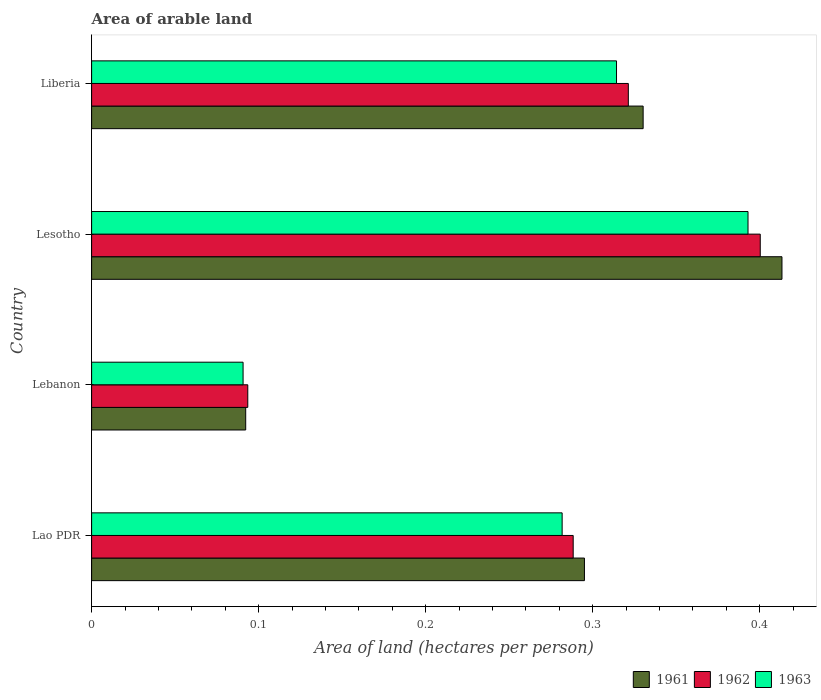How many different coloured bars are there?
Keep it short and to the point. 3. Are the number of bars on each tick of the Y-axis equal?
Offer a very short reply. Yes. How many bars are there on the 4th tick from the top?
Give a very brief answer. 3. How many bars are there on the 2nd tick from the bottom?
Make the answer very short. 3. What is the label of the 3rd group of bars from the top?
Provide a succinct answer. Lebanon. In how many cases, is the number of bars for a given country not equal to the number of legend labels?
Offer a very short reply. 0. What is the total arable land in 1961 in Lesotho?
Keep it short and to the point. 0.41. Across all countries, what is the maximum total arable land in 1963?
Keep it short and to the point. 0.39. Across all countries, what is the minimum total arable land in 1961?
Make the answer very short. 0.09. In which country was the total arable land in 1961 maximum?
Ensure brevity in your answer.  Lesotho. In which country was the total arable land in 1963 minimum?
Your answer should be compact. Lebanon. What is the total total arable land in 1962 in the graph?
Provide a succinct answer. 1.1. What is the difference between the total arable land in 1962 in Lesotho and that in Liberia?
Give a very brief answer. 0.08. What is the difference between the total arable land in 1962 in Lao PDR and the total arable land in 1961 in Liberia?
Keep it short and to the point. -0.04. What is the average total arable land in 1961 per country?
Offer a very short reply. 0.28. What is the difference between the total arable land in 1962 and total arable land in 1961 in Lebanon?
Ensure brevity in your answer.  0. What is the ratio of the total arable land in 1963 in Lesotho to that in Liberia?
Your response must be concise. 1.25. Is the total arable land in 1963 in Lebanon less than that in Lesotho?
Ensure brevity in your answer.  Yes. What is the difference between the highest and the second highest total arable land in 1962?
Your answer should be compact. 0.08. What is the difference between the highest and the lowest total arable land in 1961?
Offer a very short reply. 0.32. In how many countries, is the total arable land in 1963 greater than the average total arable land in 1963 taken over all countries?
Your answer should be very brief. 3. Is the sum of the total arable land in 1961 in Lesotho and Liberia greater than the maximum total arable land in 1963 across all countries?
Give a very brief answer. Yes. What does the 1st bar from the top in Lesotho represents?
Your answer should be compact. 1963. What does the 2nd bar from the bottom in Liberia represents?
Ensure brevity in your answer.  1962. Is it the case that in every country, the sum of the total arable land in 1961 and total arable land in 1963 is greater than the total arable land in 1962?
Provide a short and direct response. Yes. How many countries are there in the graph?
Keep it short and to the point. 4. Are the values on the major ticks of X-axis written in scientific E-notation?
Ensure brevity in your answer.  No. Does the graph contain any zero values?
Ensure brevity in your answer.  No. Does the graph contain grids?
Give a very brief answer. No. How are the legend labels stacked?
Provide a succinct answer. Horizontal. What is the title of the graph?
Ensure brevity in your answer.  Area of arable land. What is the label or title of the X-axis?
Give a very brief answer. Area of land (hectares per person). What is the Area of land (hectares per person) in 1961 in Lao PDR?
Keep it short and to the point. 0.3. What is the Area of land (hectares per person) of 1962 in Lao PDR?
Keep it short and to the point. 0.29. What is the Area of land (hectares per person) of 1963 in Lao PDR?
Give a very brief answer. 0.28. What is the Area of land (hectares per person) in 1961 in Lebanon?
Provide a short and direct response. 0.09. What is the Area of land (hectares per person) in 1962 in Lebanon?
Provide a succinct answer. 0.09. What is the Area of land (hectares per person) of 1963 in Lebanon?
Provide a succinct answer. 0.09. What is the Area of land (hectares per person) in 1961 in Lesotho?
Ensure brevity in your answer.  0.41. What is the Area of land (hectares per person) in 1962 in Lesotho?
Offer a terse response. 0.4. What is the Area of land (hectares per person) of 1963 in Lesotho?
Provide a short and direct response. 0.39. What is the Area of land (hectares per person) of 1961 in Liberia?
Offer a very short reply. 0.33. What is the Area of land (hectares per person) of 1962 in Liberia?
Offer a terse response. 0.32. What is the Area of land (hectares per person) of 1963 in Liberia?
Your answer should be compact. 0.31. Across all countries, what is the maximum Area of land (hectares per person) of 1961?
Your response must be concise. 0.41. Across all countries, what is the maximum Area of land (hectares per person) of 1962?
Your answer should be very brief. 0.4. Across all countries, what is the maximum Area of land (hectares per person) in 1963?
Ensure brevity in your answer.  0.39. Across all countries, what is the minimum Area of land (hectares per person) in 1961?
Give a very brief answer. 0.09. Across all countries, what is the minimum Area of land (hectares per person) of 1962?
Your answer should be compact. 0.09. Across all countries, what is the minimum Area of land (hectares per person) in 1963?
Provide a succinct answer. 0.09. What is the total Area of land (hectares per person) in 1961 in the graph?
Ensure brevity in your answer.  1.13. What is the total Area of land (hectares per person) of 1962 in the graph?
Your response must be concise. 1.1. What is the total Area of land (hectares per person) in 1963 in the graph?
Your answer should be very brief. 1.08. What is the difference between the Area of land (hectares per person) in 1961 in Lao PDR and that in Lebanon?
Your answer should be compact. 0.2. What is the difference between the Area of land (hectares per person) of 1962 in Lao PDR and that in Lebanon?
Keep it short and to the point. 0.19. What is the difference between the Area of land (hectares per person) in 1963 in Lao PDR and that in Lebanon?
Offer a very short reply. 0.19. What is the difference between the Area of land (hectares per person) in 1961 in Lao PDR and that in Lesotho?
Ensure brevity in your answer.  -0.12. What is the difference between the Area of land (hectares per person) of 1962 in Lao PDR and that in Lesotho?
Provide a succinct answer. -0.11. What is the difference between the Area of land (hectares per person) of 1963 in Lao PDR and that in Lesotho?
Keep it short and to the point. -0.11. What is the difference between the Area of land (hectares per person) in 1961 in Lao PDR and that in Liberia?
Your answer should be compact. -0.04. What is the difference between the Area of land (hectares per person) of 1962 in Lao PDR and that in Liberia?
Offer a terse response. -0.03. What is the difference between the Area of land (hectares per person) in 1963 in Lao PDR and that in Liberia?
Your answer should be compact. -0.03. What is the difference between the Area of land (hectares per person) in 1961 in Lebanon and that in Lesotho?
Ensure brevity in your answer.  -0.32. What is the difference between the Area of land (hectares per person) in 1962 in Lebanon and that in Lesotho?
Offer a very short reply. -0.31. What is the difference between the Area of land (hectares per person) of 1963 in Lebanon and that in Lesotho?
Your response must be concise. -0.3. What is the difference between the Area of land (hectares per person) in 1961 in Lebanon and that in Liberia?
Offer a terse response. -0.24. What is the difference between the Area of land (hectares per person) in 1962 in Lebanon and that in Liberia?
Your answer should be compact. -0.23. What is the difference between the Area of land (hectares per person) in 1963 in Lebanon and that in Liberia?
Your answer should be compact. -0.22. What is the difference between the Area of land (hectares per person) in 1961 in Lesotho and that in Liberia?
Your answer should be compact. 0.08. What is the difference between the Area of land (hectares per person) in 1962 in Lesotho and that in Liberia?
Your response must be concise. 0.08. What is the difference between the Area of land (hectares per person) in 1963 in Lesotho and that in Liberia?
Give a very brief answer. 0.08. What is the difference between the Area of land (hectares per person) in 1961 in Lao PDR and the Area of land (hectares per person) in 1962 in Lebanon?
Give a very brief answer. 0.2. What is the difference between the Area of land (hectares per person) of 1961 in Lao PDR and the Area of land (hectares per person) of 1963 in Lebanon?
Provide a short and direct response. 0.2. What is the difference between the Area of land (hectares per person) of 1962 in Lao PDR and the Area of land (hectares per person) of 1963 in Lebanon?
Your response must be concise. 0.2. What is the difference between the Area of land (hectares per person) in 1961 in Lao PDR and the Area of land (hectares per person) in 1962 in Lesotho?
Offer a terse response. -0.11. What is the difference between the Area of land (hectares per person) in 1961 in Lao PDR and the Area of land (hectares per person) in 1963 in Lesotho?
Make the answer very short. -0.1. What is the difference between the Area of land (hectares per person) in 1962 in Lao PDR and the Area of land (hectares per person) in 1963 in Lesotho?
Offer a terse response. -0.1. What is the difference between the Area of land (hectares per person) of 1961 in Lao PDR and the Area of land (hectares per person) of 1962 in Liberia?
Your answer should be compact. -0.03. What is the difference between the Area of land (hectares per person) in 1961 in Lao PDR and the Area of land (hectares per person) in 1963 in Liberia?
Offer a terse response. -0.02. What is the difference between the Area of land (hectares per person) in 1962 in Lao PDR and the Area of land (hectares per person) in 1963 in Liberia?
Give a very brief answer. -0.03. What is the difference between the Area of land (hectares per person) in 1961 in Lebanon and the Area of land (hectares per person) in 1962 in Lesotho?
Offer a terse response. -0.31. What is the difference between the Area of land (hectares per person) in 1961 in Lebanon and the Area of land (hectares per person) in 1963 in Lesotho?
Ensure brevity in your answer.  -0.3. What is the difference between the Area of land (hectares per person) of 1962 in Lebanon and the Area of land (hectares per person) of 1963 in Lesotho?
Your answer should be compact. -0.3. What is the difference between the Area of land (hectares per person) in 1961 in Lebanon and the Area of land (hectares per person) in 1962 in Liberia?
Give a very brief answer. -0.23. What is the difference between the Area of land (hectares per person) in 1961 in Lebanon and the Area of land (hectares per person) in 1963 in Liberia?
Provide a short and direct response. -0.22. What is the difference between the Area of land (hectares per person) in 1962 in Lebanon and the Area of land (hectares per person) in 1963 in Liberia?
Offer a terse response. -0.22. What is the difference between the Area of land (hectares per person) in 1961 in Lesotho and the Area of land (hectares per person) in 1962 in Liberia?
Offer a terse response. 0.09. What is the difference between the Area of land (hectares per person) of 1961 in Lesotho and the Area of land (hectares per person) of 1963 in Liberia?
Make the answer very short. 0.1. What is the difference between the Area of land (hectares per person) of 1962 in Lesotho and the Area of land (hectares per person) of 1963 in Liberia?
Ensure brevity in your answer.  0.09. What is the average Area of land (hectares per person) of 1961 per country?
Your response must be concise. 0.28. What is the average Area of land (hectares per person) of 1962 per country?
Provide a short and direct response. 0.28. What is the average Area of land (hectares per person) in 1963 per country?
Make the answer very short. 0.27. What is the difference between the Area of land (hectares per person) in 1961 and Area of land (hectares per person) in 1962 in Lao PDR?
Offer a terse response. 0.01. What is the difference between the Area of land (hectares per person) of 1961 and Area of land (hectares per person) of 1963 in Lao PDR?
Ensure brevity in your answer.  0.01. What is the difference between the Area of land (hectares per person) of 1962 and Area of land (hectares per person) of 1963 in Lao PDR?
Make the answer very short. 0.01. What is the difference between the Area of land (hectares per person) of 1961 and Area of land (hectares per person) of 1962 in Lebanon?
Offer a very short reply. -0. What is the difference between the Area of land (hectares per person) of 1961 and Area of land (hectares per person) of 1963 in Lebanon?
Offer a very short reply. 0. What is the difference between the Area of land (hectares per person) in 1962 and Area of land (hectares per person) in 1963 in Lebanon?
Keep it short and to the point. 0. What is the difference between the Area of land (hectares per person) in 1961 and Area of land (hectares per person) in 1962 in Lesotho?
Your response must be concise. 0.01. What is the difference between the Area of land (hectares per person) of 1961 and Area of land (hectares per person) of 1963 in Lesotho?
Make the answer very short. 0.02. What is the difference between the Area of land (hectares per person) of 1962 and Area of land (hectares per person) of 1963 in Lesotho?
Your answer should be very brief. 0.01. What is the difference between the Area of land (hectares per person) in 1961 and Area of land (hectares per person) in 1962 in Liberia?
Your answer should be compact. 0.01. What is the difference between the Area of land (hectares per person) in 1961 and Area of land (hectares per person) in 1963 in Liberia?
Offer a very short reply. 0.02. What is the difference between the Area of land (hectares per person) in 1962 and Area of land (hectares per person) in 1963 in Liberia?
Give a very brief answer. 0.01. What is the ratio of the Area of land (hectares per person) in 1961 in Lao PDR to that in Lebanon?
Your response must be concise. 3.2. What is the ratio of the Area of land (hectares per person) in 1962 in Lao PDR to that in Lebanon?
Ensure brevity in your answer.  3.08. What is the ratio of the Area of land (hectares per person) of 1963 in Lao PDR to that in Lebanon?
Your response must be concise. 3.11. What is the ratio of the Area of land (hectares per person) in 1961 in Lao PDR to that in Lesotho?
Provide a short and direct response. 0.71. What is the ratio of the Area of land (hectares per person) of 1962 in Lao PDR to that in Lesotho?
Provide a short and direct response. 0.72. What is the ratio of the Area of land (hectares per person) of 1963 in Lao PDR to that in Lesotho?
Offer a terse response. 0.72. What is the ratio of the Area of land (hectares per person) in 1961 in Lao PDR to that in Liberia?
Ensure brevity in your answer.  0.89. What is the ratio of the Area of land (hectares per person) of 1962 in Lao PDR to that in Liberia?
Provide a succinct answer. 0.9. What is the ratio of the Area of land (hectares per person) in 1963 in Lao PDR to that in Liberia?
Provide a short and direct response. 0.9. What is the ratio of the Area of land (hectares per person) in 1961 in Lebanon to that in Lesotho?
Make the answer very short. 0.22. What is the ratio of the Area of land (hectares per person) in 1962 in Lebanon to that in Lesotho?
Give a very brief answer. 0.23. What is the ratio of the Area of land (hectares per person) of 1963 in Lebanon to that in Lesotho?
Provide a succinct answer. 0.23. What is the ratio of the Area of land (hectares per person) in 1961 in Lebanon to that in Liberia?
Give a very brief answer. 0.28. What is the ratio of the Area of land (hectares per person) of 1962 in Lebanon to that in Liberia?
Your response must be concise. 0.29. What is the ratio of the Area of land (hectares per person) in 1963 in Lebanon to that in Liberia?
Provide a succinct answer. 0.29. What is the ratio of the Area of land (hectares per person) in 1961 in Lesotho to that in Liberia?
Make the answer very short. 1.25. What is the ratio of the Area of land (hectares per person) in 1962 in Lesotho to that in Liberia?
Provide a short and direct response. 1.25. What is the ratio of the Area of land (hectares per person) in 1963 in Lesotho to that in Liberia?
Provide a short and direct response. 1.25. What is the difference between the highest and the second highest Area of land (hectares per person) in 1961?
Offer a very short reply. 0.08. What is the difference between the highest and the second highest Area of land (hectares per person) of 1962?
Your answer should be compact. 0.08. What is the difference between the highest and the second highest Area of land (hectares per person) of 1963?
Offer a terse response. 0.08. What is the difference between the highest and the lowest Area of land (hectares per person) in 1961?
Your response must be concise. 0.32. What is the difference between the highest and the lowest Area of land (hectares per person) of 1962?
Offer a very short reply. 0.31. What is the difference between the highest and the lowest Area of land (hectares per person) in 1963?
Provide a short and direct response. 0.3. 